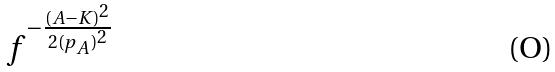Convert formula to latex. <formula><loc_0><loc_0><loc_500><loc_500>f ^ { - \frac { ( A - K ) ^ { 2 } } { 2 { ( p _ { A } ) } ^ { 2 } } }</formula> 